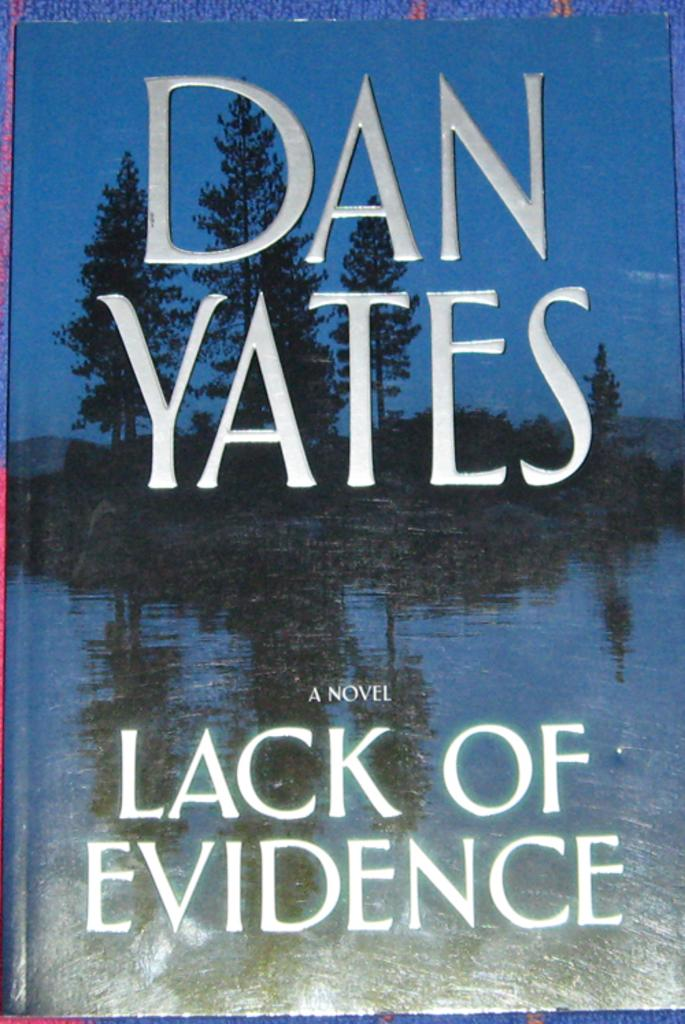<image>
Create a compact narrative representing the image presented. Dan Yates wrote a novel called Lack of Evidence 